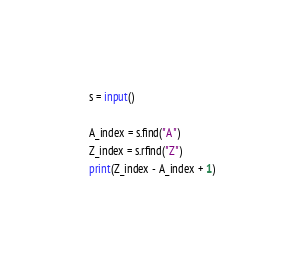Convert code to text. <code><loc_0><loc_0><loc_500><loc_500><_Python_>s = input()

A_index = s.find("A")
Z_index = s.rfind("Z")
print(Z_index - A_index + 1)</code> 